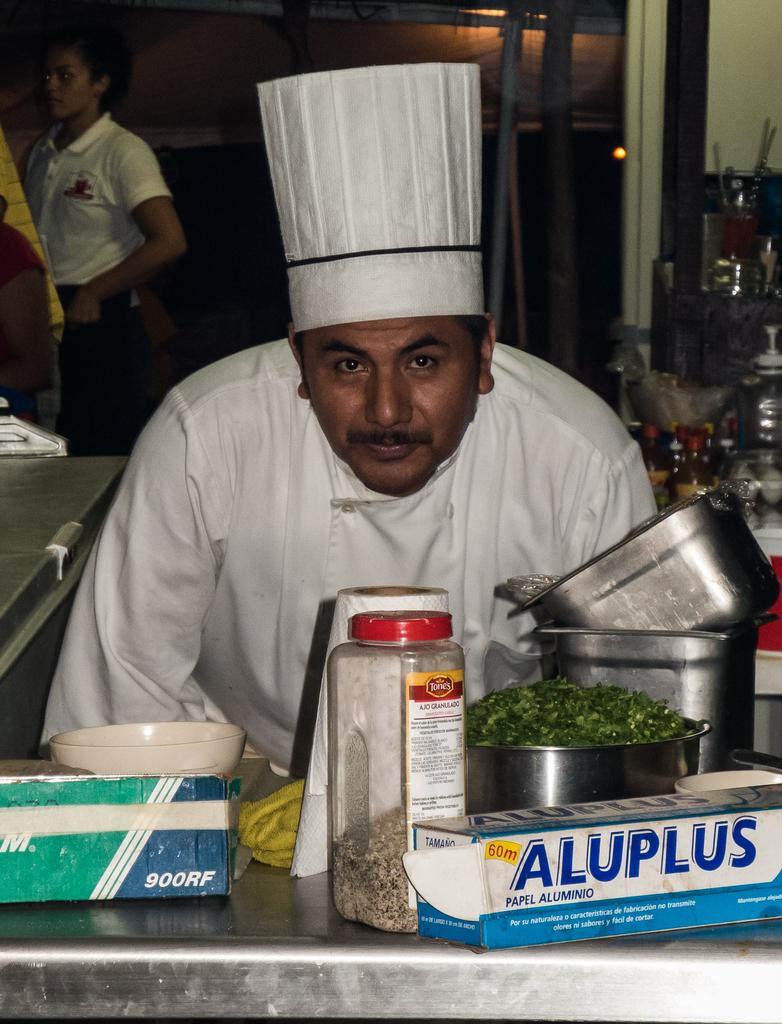What is the man in the image wearing on his head? The man in the image is wearing a cap. What type of objects can be seen in the image besides the man? There are boxes, containers, vegetable leaves, and objects on a table in the image. Can you describe the background of the image? In the background of the image, there is a wall, bottles, and other objects. Are there any other people visible in the image? Yes, there are persons in the background of the image. What type of pets can be seen playing with the vegetable leaves in the image? There are no pets visible in the image, and vegetable leaves are not something that pets would typically play with. 